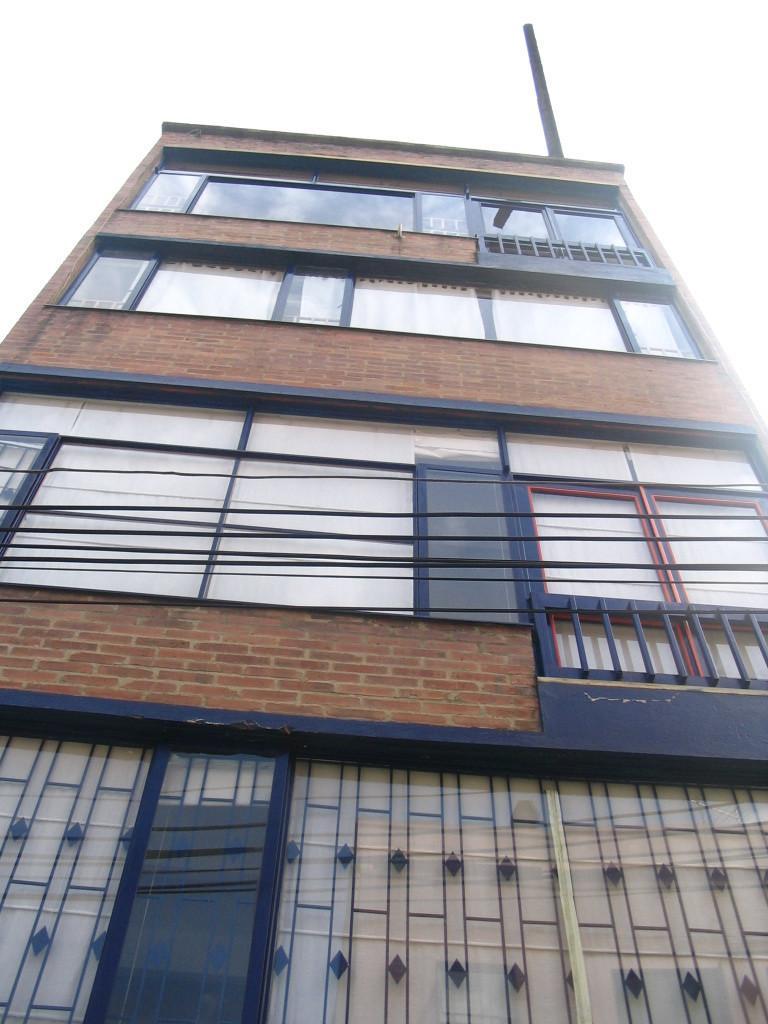Could you give a brief overview of what you see in this image? In this image there is a big building with glasses. 